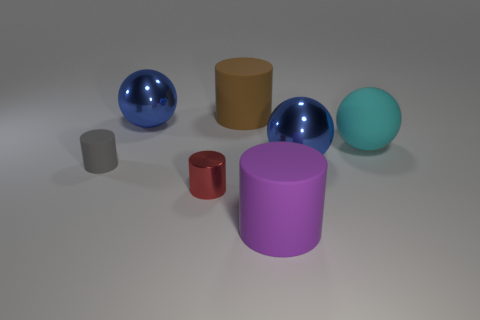Is there any other thing that has the same shape as the tiny gray thing?
Provide a succinct answer. Yes. What is the color of the thing in front of the small thing that is to the right of the big sphere on the left side of the metal cylinder?
Offer a terse response. Purple. What number of large objects are gray things or shiny spheres?
Ensure brevity in your answer.  2. Are there the same number of tiny shiny objects that are left of the gray rubber thing and brown objects?
Give a very brief answer. No. Are there any matte spheres left of the tiny red metallic object?
Provide a succinct answer. No. How many rubber things are either green blocks or purple cylinders?
Provide a short and direct response. 1. There is a cyan ball; what number of cyan rubber spheres are left of it?
Provide a short and direct response. 0. Are there any other cyan spheres that have the same size as the cyan sphere?
Provide a short and direct response. No. What number of tiny metallic cylinders are the same color as the big matte ball?
Your answer should be very brief. 0. What number of things are either red shiny objects or large cylinders that are behind the big cyan matte sphere?
Make the answer very short. 2. 